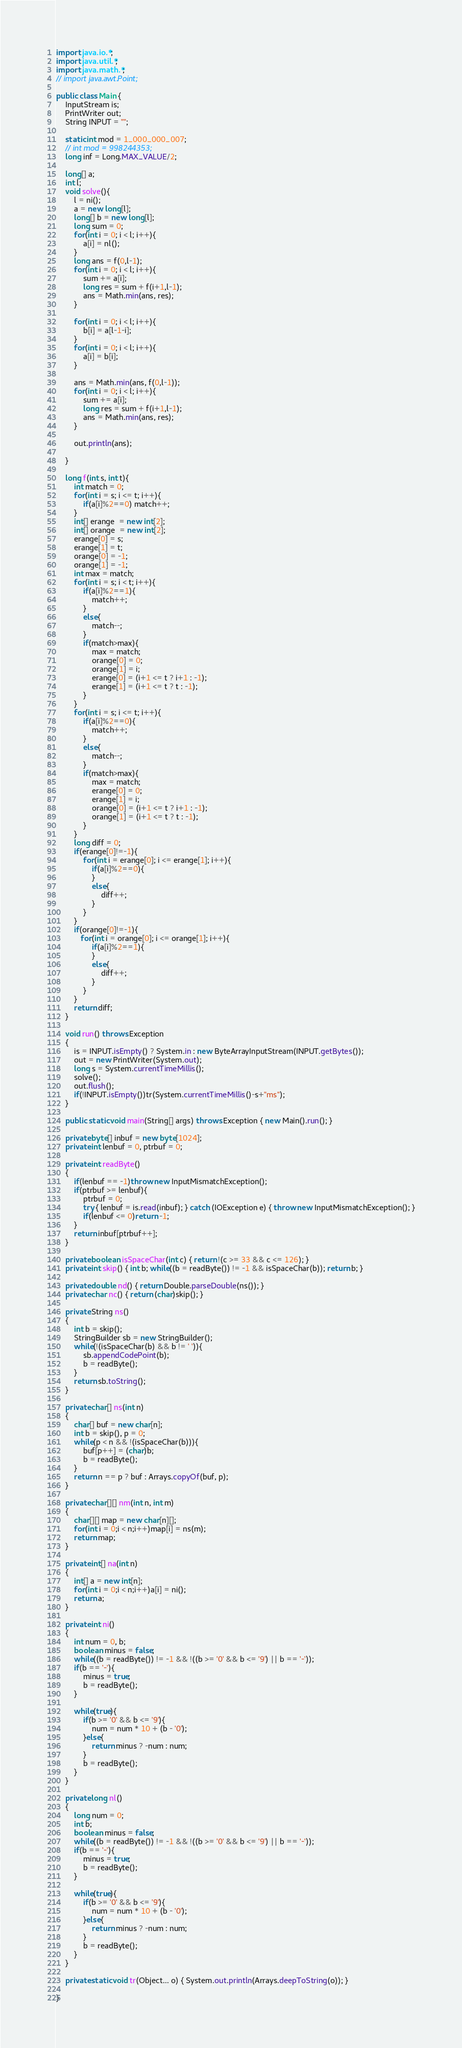<code> <loc_0><loc_0><loc_500><loc_500><_Java_>import java.io.*;
import java.util.*;
import java.math.*;
// import java.awt.Point;
 
public class Main {
    InputStream is;
    PrintWriter out;
    String INPUT = "";
 
    static int mod = 1_000_000_007;
    // int mod = 998244353;
    long inf = Long.MAX_VALUE/2;

    long[] a;
    int l;
    void solve(){
        l = ni();
        a = new long[l];
        long[] b = new long[l];
        long sum = 0;
        for(int i = 0; i < l; i++){
            a[i] = nl();
        }
        long ans = f(0,l-1);
        for(int i = 0; i < l; i++){
            sum += a[i];
            long res = sum + f(i+1,l-1);
            ans = Math.min(ans, res);
        }

        for(int i = 0; i < l; i++){
            b[i] = a[l-1-i];
        }
        for(int i = 0; i < l; i++){
            a[i] = b[i];
        }

        ans = Math.min(ans, f(0,l-1));
        for(int i = 0; i < l; i++){
            sum += a[i];
            long res = sum + f(i+1,l-1);
            ans = Math.min(ans, res);
        }
        
        out.println(ans);

    }

    long f(int s, int t){
        int match = 0;
        for(int i = s; i <= t; i++){
            if(a[i]%2==0) match++;
        }
        int[] erange  = new int[2];
        int[] orange  = new int[2];
        erange[0] = s;
        erange[1] = t;
        orange[0] = -1;
        orange[1] = -1;
        int max = match;
        for(int i = s; i < t; i++){
            if(a[i]%2==1){
                match++;
            }
            else{
                match--;
            }
            if(match>max){
                max = match;
                orange[0] = 0;
                orange[1] = i;
                erange[0] = (i+1 <= t ? i+1 : -1);
                erange[1] = (i+1 <= t ? t : -1);
            }
        }
        for(int i = s; i <= t; i++){
            if(a[i]%2==0){
                match++;
            }
            else{
                match--;
            }
            if(match>max){
                max = match;
                erange[0] = 0;
                erange[1] = i;
                orange[0] = (i+1 <= t ? i+1 : -1);
                orange[1] = (i+1 <= t ? t : -1);
            }
        }
        long diff = 0;
        if(erange[0]!=-1){
            for(int i = erange[0]; i <= erange[1]; i++){
                if(a[i]%2==0){
                }
                else{
                    diff++;
                }
            }
        }
        if(orange[0]!=-1){
           for(int i = orange[0]; i <= orange[1]; i++){
                if(a[i]%2==1){
                }
                else{
                    diff++;
                }
            } 
        }
        return diff;
    }

    void run() throws Exception
    {
        is = INPUT.isEmpty() ? System.in : new ByteArrayInputStream(INPUT.getBytes());
        out = new PrintWriter(System.out);
        long s = System.currentTimeMillis();
        solve();
        out.flush();
        if(!INPUT.isEmpty())tr(System.currentTimeMillis()-s+"ms");
    }
    
    public static void main(String[] args) throws Exception { new Main().run(); }
    
    private byte[] inbuf = new byte[1024];
    private int lenbuf = 0, ptrbuf = 0;
    
    private int readByte()
    {
        if(lenbuf == -1)throw new InputMismatchException();
        if(ptrbuf >= lenbuf){
            ptrbuf = 0;
            try { lenbuf = is.read(inbuf); } catch (IOException e) { throw new InputMismatchException(); }
            if(lenbuf <= 0)return -1;
        }
        return inbuf[ptrbuf++];
    }
    
    private boolean isSpaceChar(int c) { return !(c >= 33 && c <= 126); }
    private int skip() { int b; while((b = readByte()) != -1 && isSpaceChar(b)); return b; }
    
    private double nd() { return Double.parseDouble(ns()); }
    private char nc() { return (char)skip(); }
    
    private String ns()
    {
        int b = skip();
        StringBuilder sb = new StringBuilder();
        while(!(isSpaceChar(b) && b != ' ')){
            sb.appendCodePoint(b);
            b = readByte();
        }
        return sb.toString();
    }
    
    private char[] ns(int n)
    {
        char[] buf = new char[n];
        int b = skip(), p = 0;
        while(p < n && !(isSpaceChar(b))){
            buf[p++] = (char)b;
            b = readByte();
        }
        return n == p ? buf : Arrays.copyOf(buf, p);
    }
    
    private char[][] nm(int n, int m)
    {
        char[][] map = new char[n][];
        for(int i = 0;i < n;i++)map[i] = ns(m);
        return map;
    }
    
    private int[] na(int n)
    {
        int[] a = new int[n];
        for(int i = 0;i < n;i++)a[i] = ni();
        return a;
    }
    
    private int ni()
    {
        int num = 0, b;
        boolean minus = false;
        while((b = readByte()) != -1 && !((b >= '0' && b <= '9') || b == '-'));
        if(b == '-'){
            minus = true;
            b = readByte();
        }
        
        while(true){
            if(b >= '0' && b <= '9'){
                num = num * 10 + (b - '0');
            }else{
                return minus ? -num : num;
            }
            b = readByte();
        }
    }
    
    private long nl()
    {
        long num = 0;
        int b;
        boolean minus = false;
        while((b = readByte()) != -1 && !((b >= '0' && b <= '9') || b == '-'));
        if(b == '-'){
            minus = true;
            b = readByte();
        }
        
        while(true){
            if(b >= '0' && b <= '9'){
                num = num * 10 + (b - '0');
            }else{
                return minus ? -num : num;
            }
            b = readByte();
        }
    }
    
    private static void tr(Object... o) { System.out.println(Arrays.deepToString(o)); }
 
}
</code> 